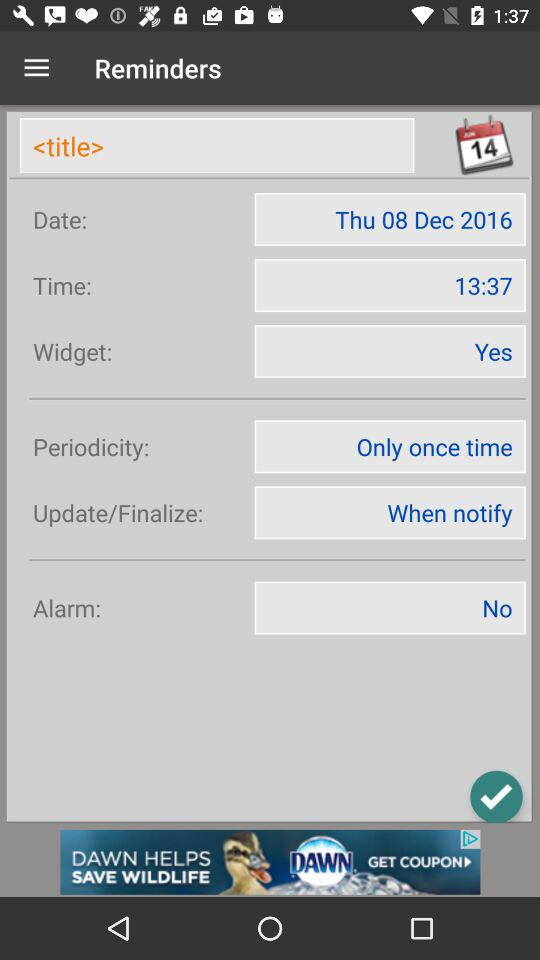What is the given periodicity? The given periodicity is "Only once time". 